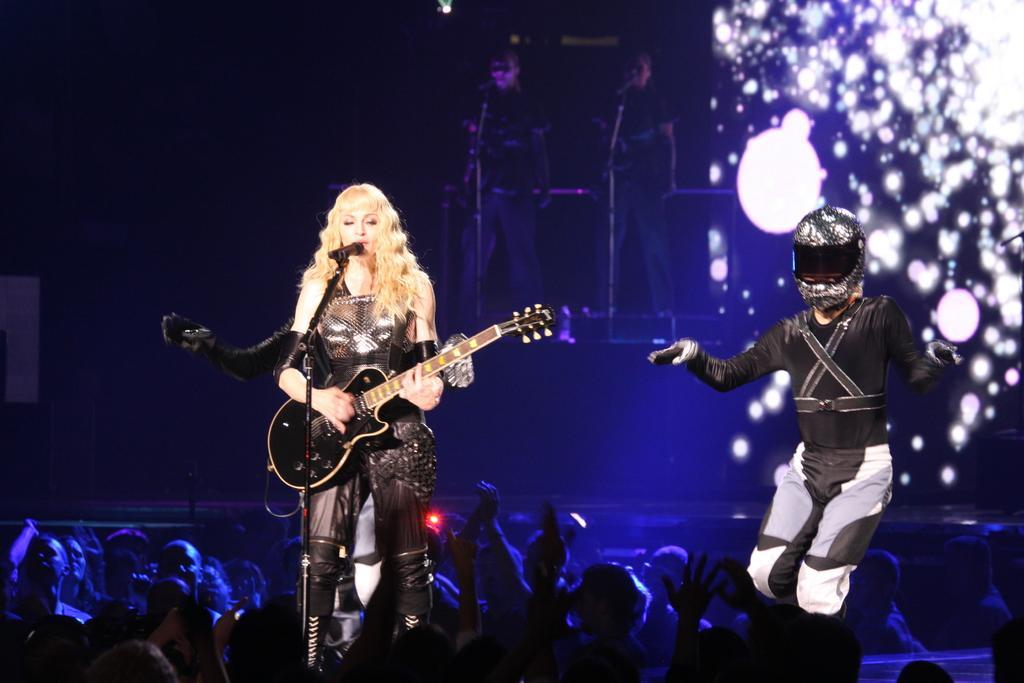Could you give a brief overview of what you see in this image? This picture seems to be clicked inside the hall. In the foreground we can see the group of people seems to be standing. On the right we can see a person wearing a helmet and seems to be standing. On the left there is a woman standing, playing a guitar and seems to be singing and we can see a microphone is attached to the metal stand. In the background we can see the two people standing and we can see the microphones like objects and some other objects. On the right we can see the objects which seems to be the lights. 